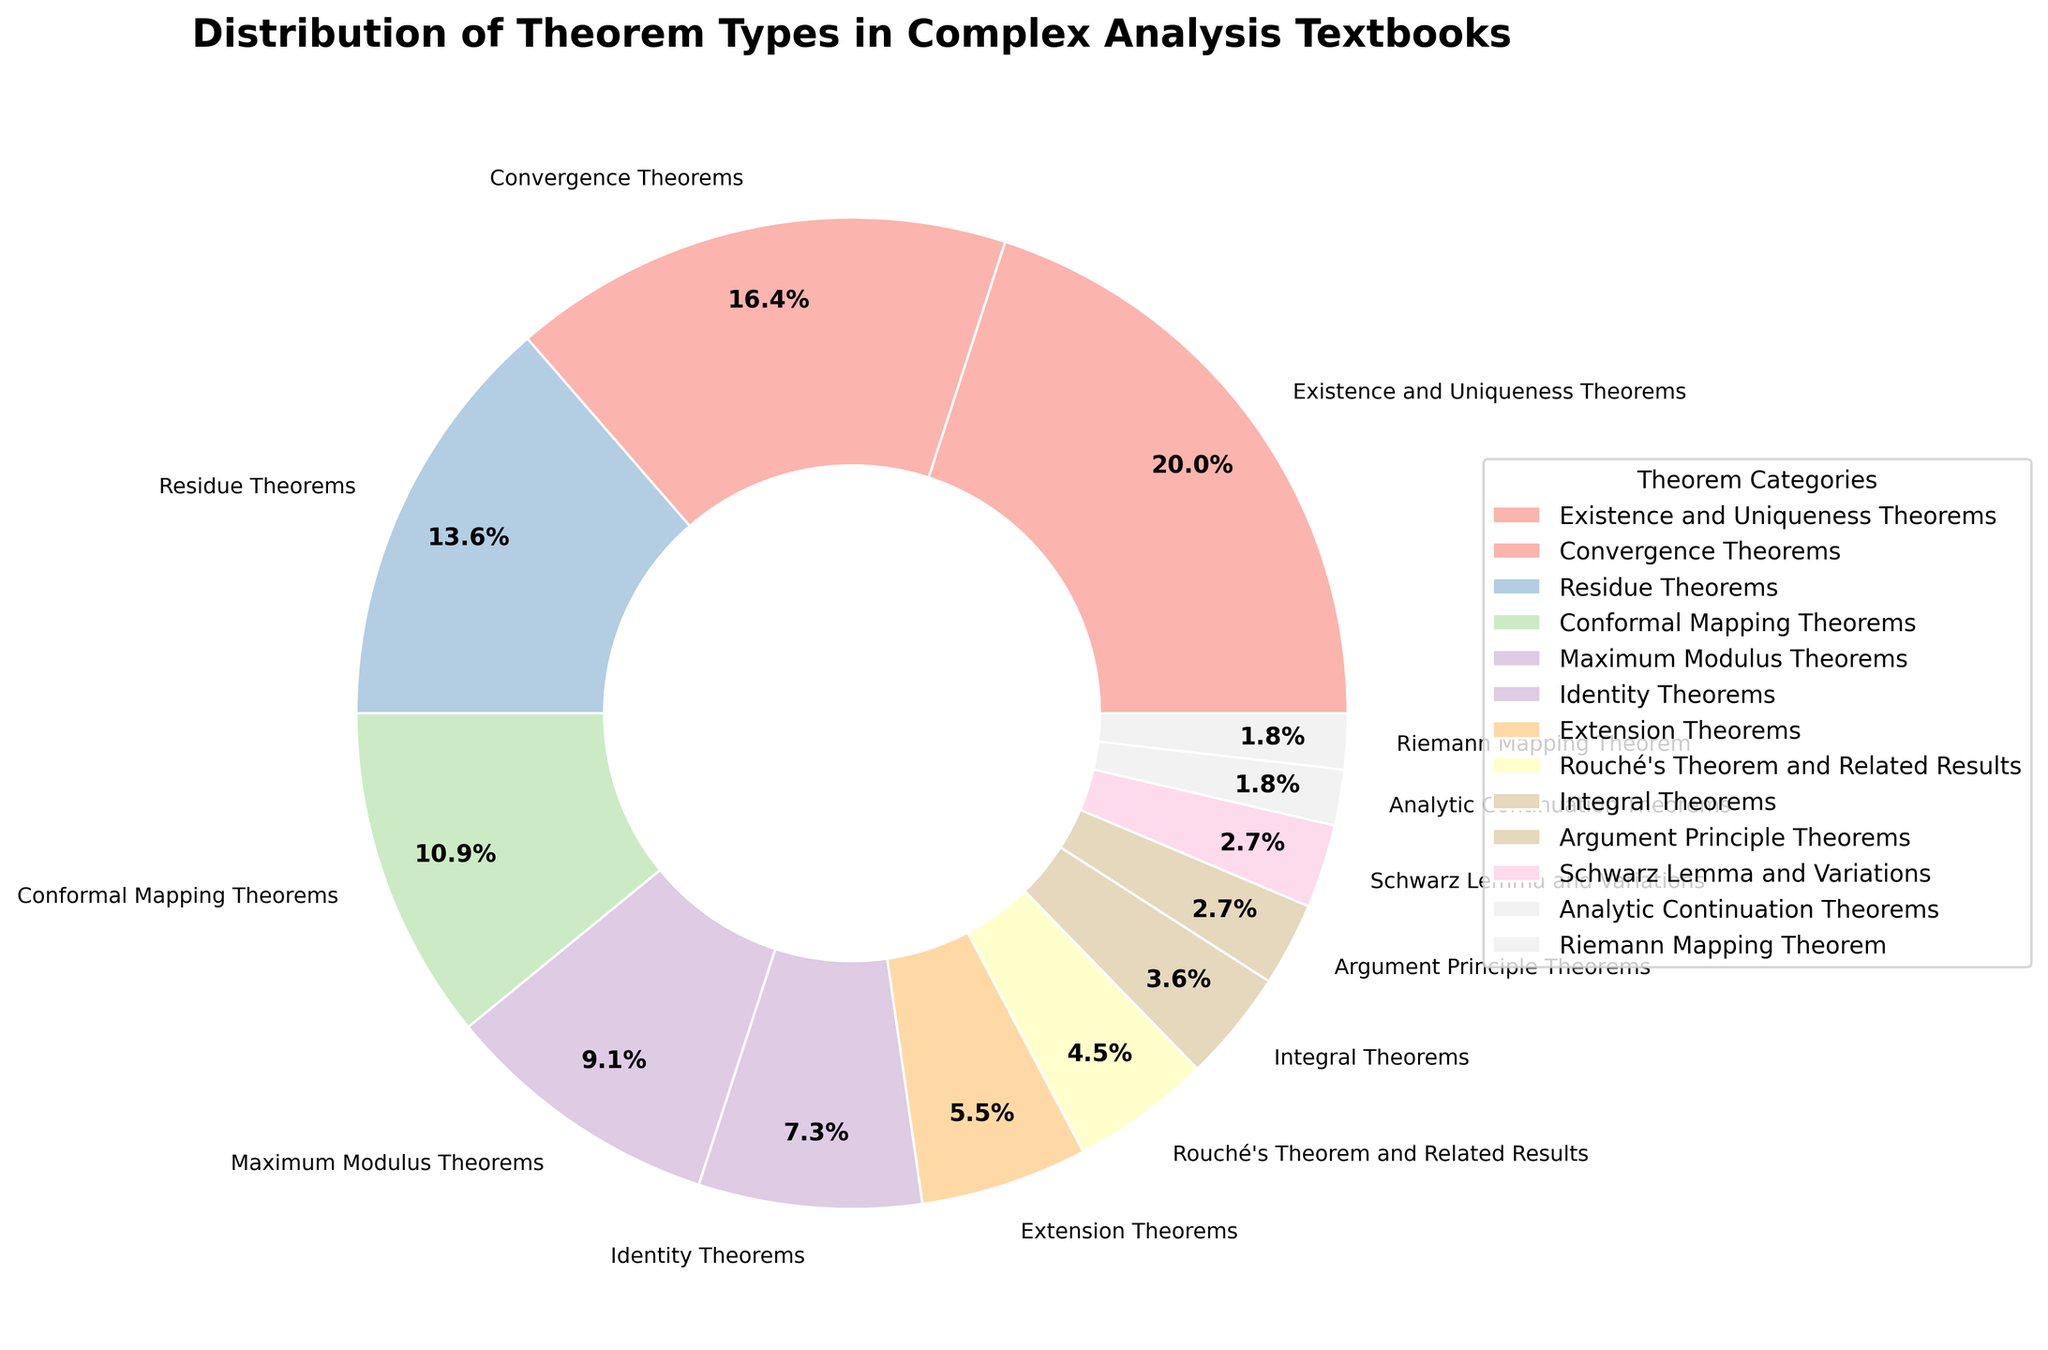what category has the highest percentage? The category with the highest percentage is easily observable since pie charts visually display proportions. By looking at the figure, we can see that "Existence and Uniqueness Theorems" occupies the largest section.
Answer: Existence and Uniqueness Theorems How many categories have a percentage less than 5%? To find the number of categories with a percentage less than 5%, we look at the labels and their corresponding percentages in the pie chart to count how many are below 5%. "Integral Theorems," "Argument Principle Theorems," "Schwarz Lemma and Variations," "Analytic Continuation Theorems," and "Riemann Mapping Theorem" each have less than 5%. This makes a total of 5 categories.
Answer: 5 What is the combined percentage of "Maximum Modulus Theorems," "Identity Theorems," and "Extension Theorems"? To find the combined percentage, sum the individual percentages of these three categories. Maximum Modulus Theorems is 10%, Identity Theorems is 8%, and Extension Theorems is 6%. Adding these together: 10 + 8 + 6 = 24%.
Answer: 24% Which theorem types make up more than 10% of the total? We need to identify the categories whose percentages exceed 10%. From the pie chart, "Existence and Uniqueness Theorems" (22%), "Convergence Theorems" (18%), "Residue Theorems" (15%), and "Conformal Mapping Theorems" (12%) all make up more than 10%.
Answer: Existence and Uniqueness Theorems, Convergence Theorems, Residue Theorems, Conformal Mapping Theorems What is the difference in percentage between "Conformal Mapping Theorems" and "Argument Principle Theorems"? Calculate the percentage difference by subtracting the percentage of "Argument Principle Theorems" (3%) from "Conformal Mapping Theorems" (12%). The difference is 12 - 3 = 9%.
Answer: 9% Which theorem type has the smallest representation? The theorem type with the smallest representation can be identified by looking for the smallest slice in the pie chart, which is labeled "Riemann Mapping Theorem" with a percentage of 2%.
Answer: Riemann Mapping Theorem What is the ratio of "Residue Theorems" to "Integral Theorems" in terms of their percentages? To find the ratio, divide the percentage of "Residue Theorems" (15%) by the percentage of "Integral Theorems" (4%). The ratio is 15:4 or approximately 3.75.
Answer: 15:4 or 3.75 If you combine the percentages of "Rouché's Theorem and Related Results" and "Integral Theorems," does it exceed "Identity Theorems"? By adding the percentages of "Rouché's Theorem and Related Results" (5%) and "Integral Theorems" (4%), we get 5 + 4 = 9%. Compare this to "Identity Theorems" which is 8%. Therefore, 9% is greater than 8%.
Answer: Yes Why do you think "Existence and Uniqueness Theorems" might have the highest percentage? This question requires interpretation based on knowledge of complex analysis. "Existence and Uniqueness Theorems" could be foundational and widely applicable across various problems in complex analysis, thus having higher coverage in textbooks.
Answer: Foundational importance How does the slice representing "Conformal Mapping Theorems" visually compare to "Maximum Modulus Theorems"? By visually comparing the slices in the pie chart, the slice for "Conformal Mapping Theorems" (12%) is slightly larger than that for "Maximum Modulus Theorems" (10%).
Answer: Slightly larger 